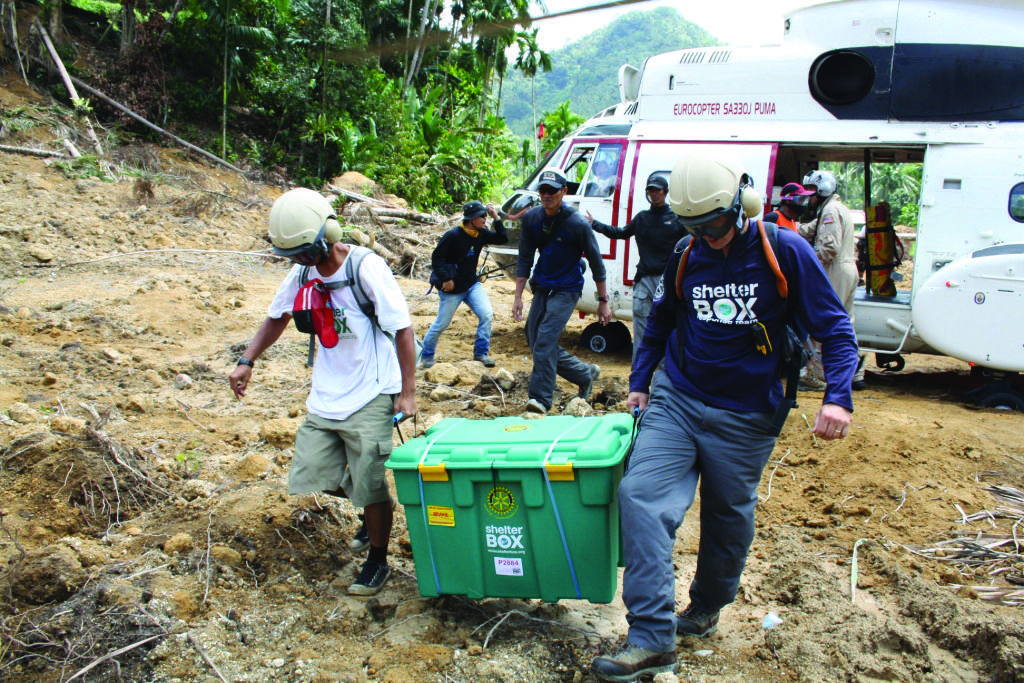Can you describe this image briefly? In this picture there are two persons holding the object and walking. At the back there are group of people walking and there is an aircraft. At the back there are trees and there is a mountain. At the top there is sky. At the bottom there is mud. 